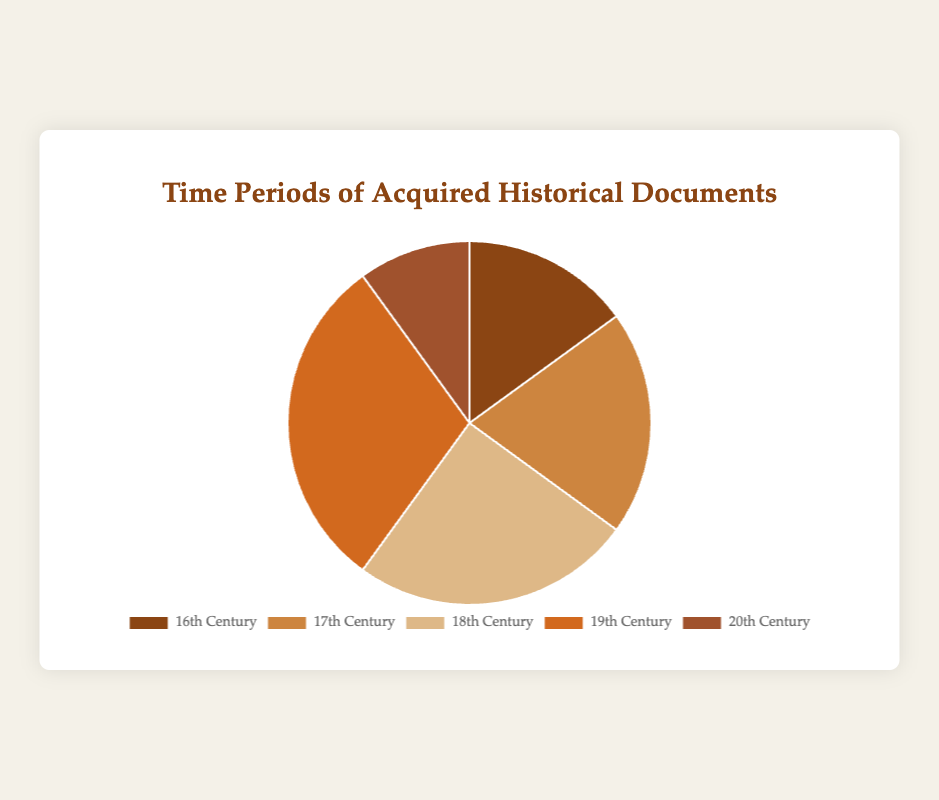What percentage of the acquired historical documents are from the 16th Century? The pie chart displays that the 16th Century represents 15% of the total historical documents.
Answer: 15% Which century has the largest proportion of acquired historical documents? By examining the pie chart, we can see that the 19th Century has the largest segment, indicating it represents the highest proportion.
Answer: 19th Century What is the total percentage of historical documents acquired from the 18th and 20th centuries combined? According to the pie chart, the 18th Century represents 25% and the 20th Century represents 10%. Summing these values gives us 25% + 10% = 35%.
Answer: 35% How much larger is the proportion of historical documents from the 19th Century compared to the 20th Century? The 19th Century represents 30% of the documents, while the 20th Century represents 10%. The difference between these proportions is 30% - 10% = 20%.
Answer: 20% Which century's document segment is represented in a darker brown color? Observing the colors in the pie chart, the 16th Century's segment appears in a darker brown color.
Answer: 16th Century What is the average percentage of documents acquired per century? To find the average, add up all the percentages and divide by the number of centuries: (15% + 20% + 25% + 30% + 10%) / 5 = 100% / 5 = 20%.
Answer: 20% Which of the centuries provided fewer documents than the 17th Century? From the pie chart, the 17th Century represents 20%. The centuries that have fewer documents are the 16th Century (15%) and 20th Century (10%).
Answer: 16th Century, 20th Century How many more documents were acquired from the 18th Century compared to the 16th Century? The 18th Century represents 25%, and the 16th Century represents 15%. The difference is 25% - 15% = 10%.
Answer: 10% 